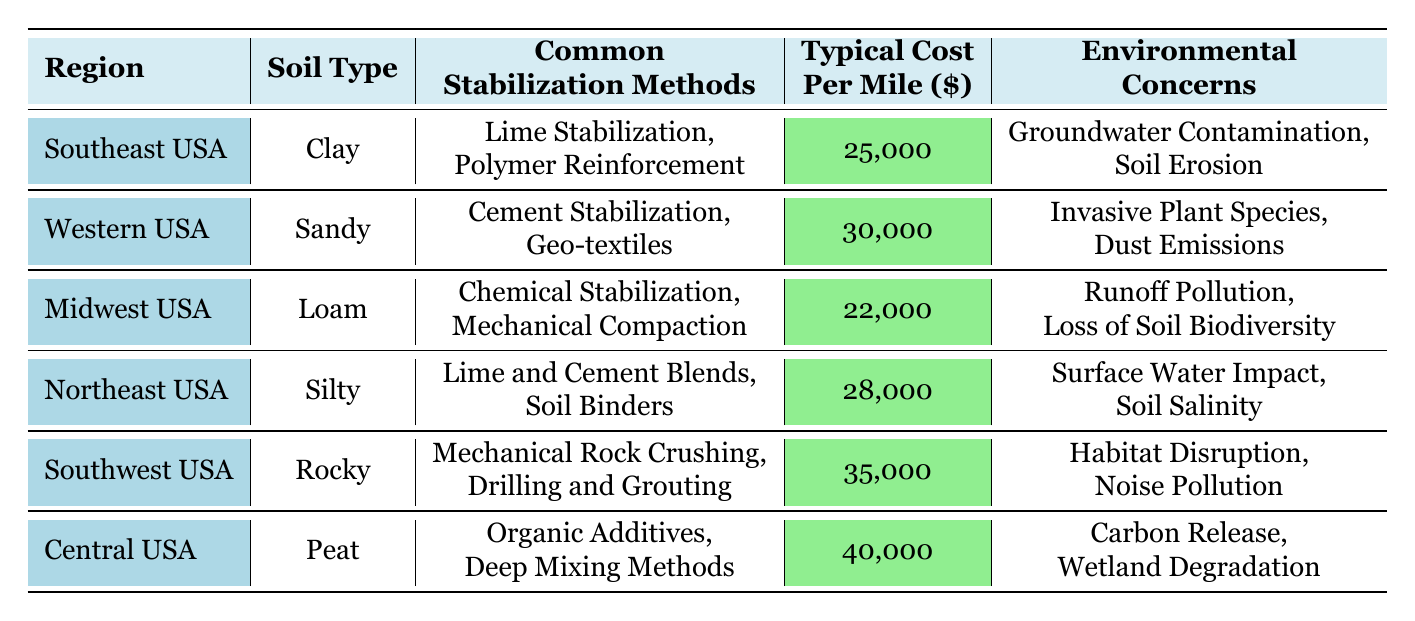What is the common stabilization method used in the Southeast USA? The table lists "Lime Stabilization" and "Polymer Reinforcement" as the common stabilization methods for the Southeast USA.
Answer: Lime Stabilization, Polymer Reinforcement What is the typical cost per mile for soil stabilization in the Midwest USA? According to the table, the typical cost per mile for soil stabilization in the Midwest USA is 22,000.
Answer: 22,000 Which region has the lowest typical cost per mile? The table shows that the Midwest USA has the lowest typical cost per mile at 22,000.
Answer: Midwest USA Are there any environmental concerns related to soil stabilization in the Southwest USA? Yes, the table lists "Habitat Disruption" and "Noise Pollution" as environmental concerns in the Southwest USA.
Answer: Yes What is the average typical cost per mile across all regions? To calculate the average: (25000 + 30000 + 22000 + 28000 + 35000 + 40000) = 180000, then divide by 6 regions, so 180000 / 6 = 30000.
Answer: 30,000 Which soil type is associated with the highest typical cost per mile, and what is that cost? The table indicates that Peat in Central USA has the highest typical cost per mile at 40,000.
Answer: Peat, 40,000 Is "Runoff Pollution" listed as an environmental concern for any region? Yes, "Runoff Pollution" is noted as an environmental concern for the Midwest USA.
Answer: Yes How many common stabilization methods are listed for the Northeast USA? The table specifies two common stabilization methods for the Northeast USA, which are "Lime and Cement Blends" and "Soil Binders."
Answer: 2 Which region uses "Mechanical Rock Crushing" as a stabilization method? The Southwest USA utilizes "Mechanical Rock Crushing" as one of its stabilization methods.
Answer: Southwest USA If you combine the costs per mile of the Southeast and Northeast USA, what would be the total? The costs for Southeast and Northeast USA are 25,000 and 28,000 respectively. Adding them gives 25,000 + 28,000 = 53,000.
Answer: 53,000 